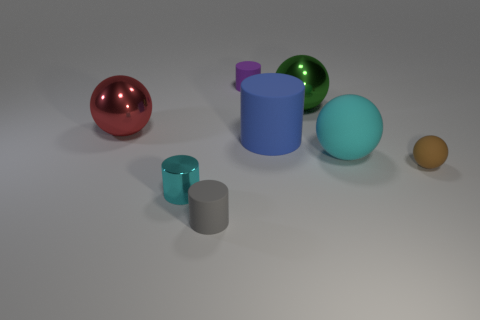Subtract 1 cylinders. How many cylinders are left? 3 Add 1 big cyan cylinders. How many objects exist? 9 Subtract all blue balls. Subtract all yellow blocks. How many balls are left? 4 Add 3 cyan balls. How many cyan balls are left? 4 Add 7 large blue cylinders. How many large blue cylinders exist? 8 Subtract 0 blue blocks. How many objects are left? 8 Subtract all things. Subtract all gray rubber blocks. How many objects are left? 0 